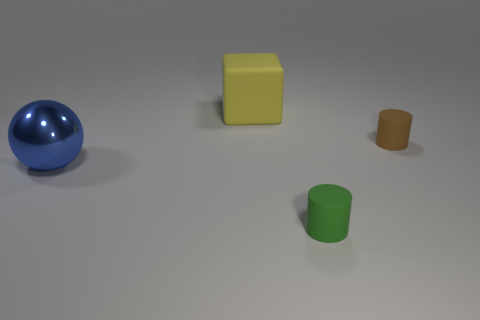Add 4 tiny brown rubber cylinders. How many objects exist? 8 Subtract all spheres. How many objects are left? 3 Subtract 0 green blocks. How many objects are left? 4 Subtract all tiny matte cylinders. Subtract all tiny green matte cylinders. How many objects are left? 1 Add 3 green matte things. How many green matte things are left? 4 Add 2 tiny gray metallic cylinders. How many tiny gray metallic cylinders exist? 2 